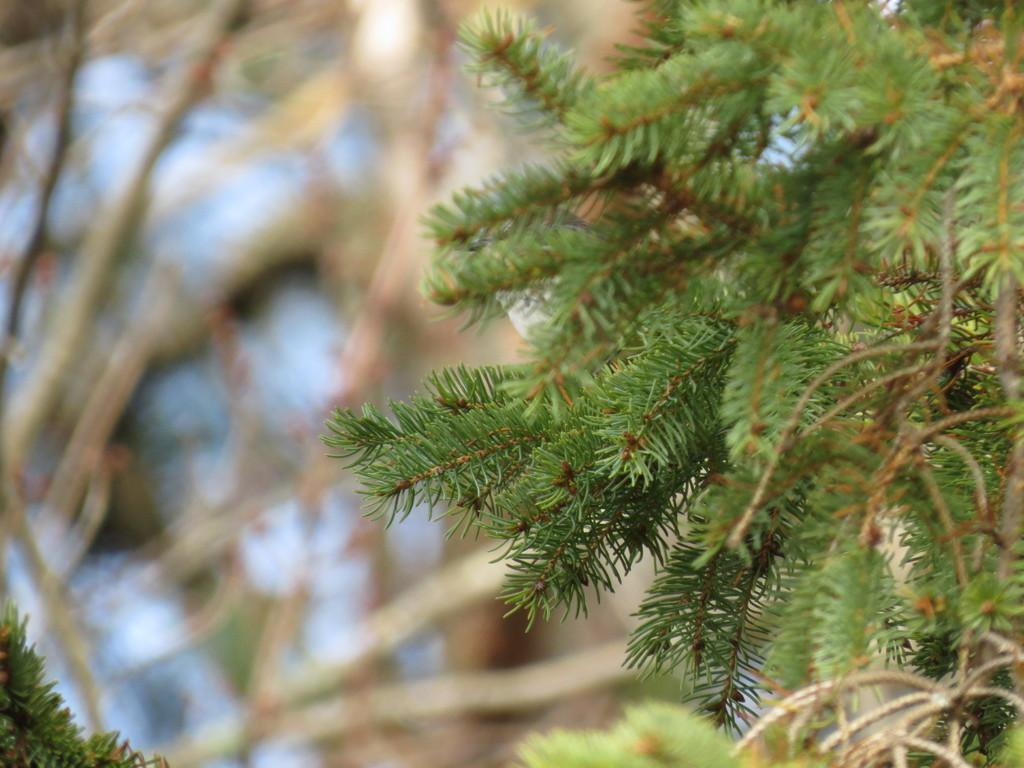What is the main subject of the image? There is a tree in the image. Can you describe the colors of the tree? The tree has green and brown colors. What can be seen in the background of the image? The background of the image is blurry, and there are trees and the sky visible. What is the birth date of the tree in the image? There is no information about the tree's birth date in the image. Trees do not have birth dates like humans do. 